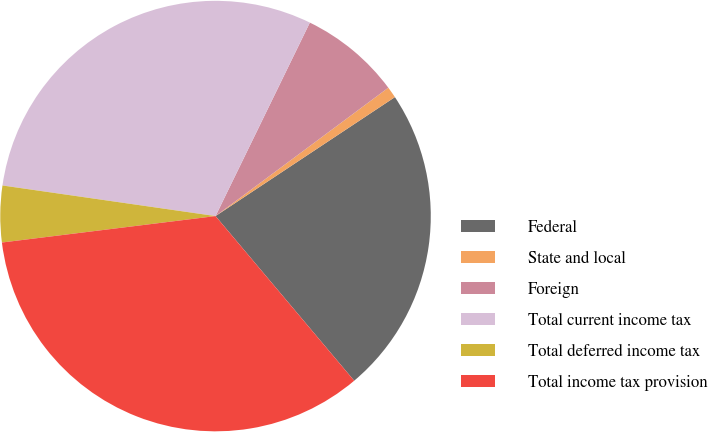Convert chart. <chart><loc_0><loc_0><loc_500><loc_500><pie_chart><fcel>Federal<fcel>State and local<fcel>Foreign<fcel>Total current income tax<fcel>Total deferred income tax<fcel>Total income tax provision<nl><fcel>23.18%<fcel>0.85%<fcel>7.61%<fcel>29.95%<fcel>4.23%<fcel>34.18%<nl></chart> 